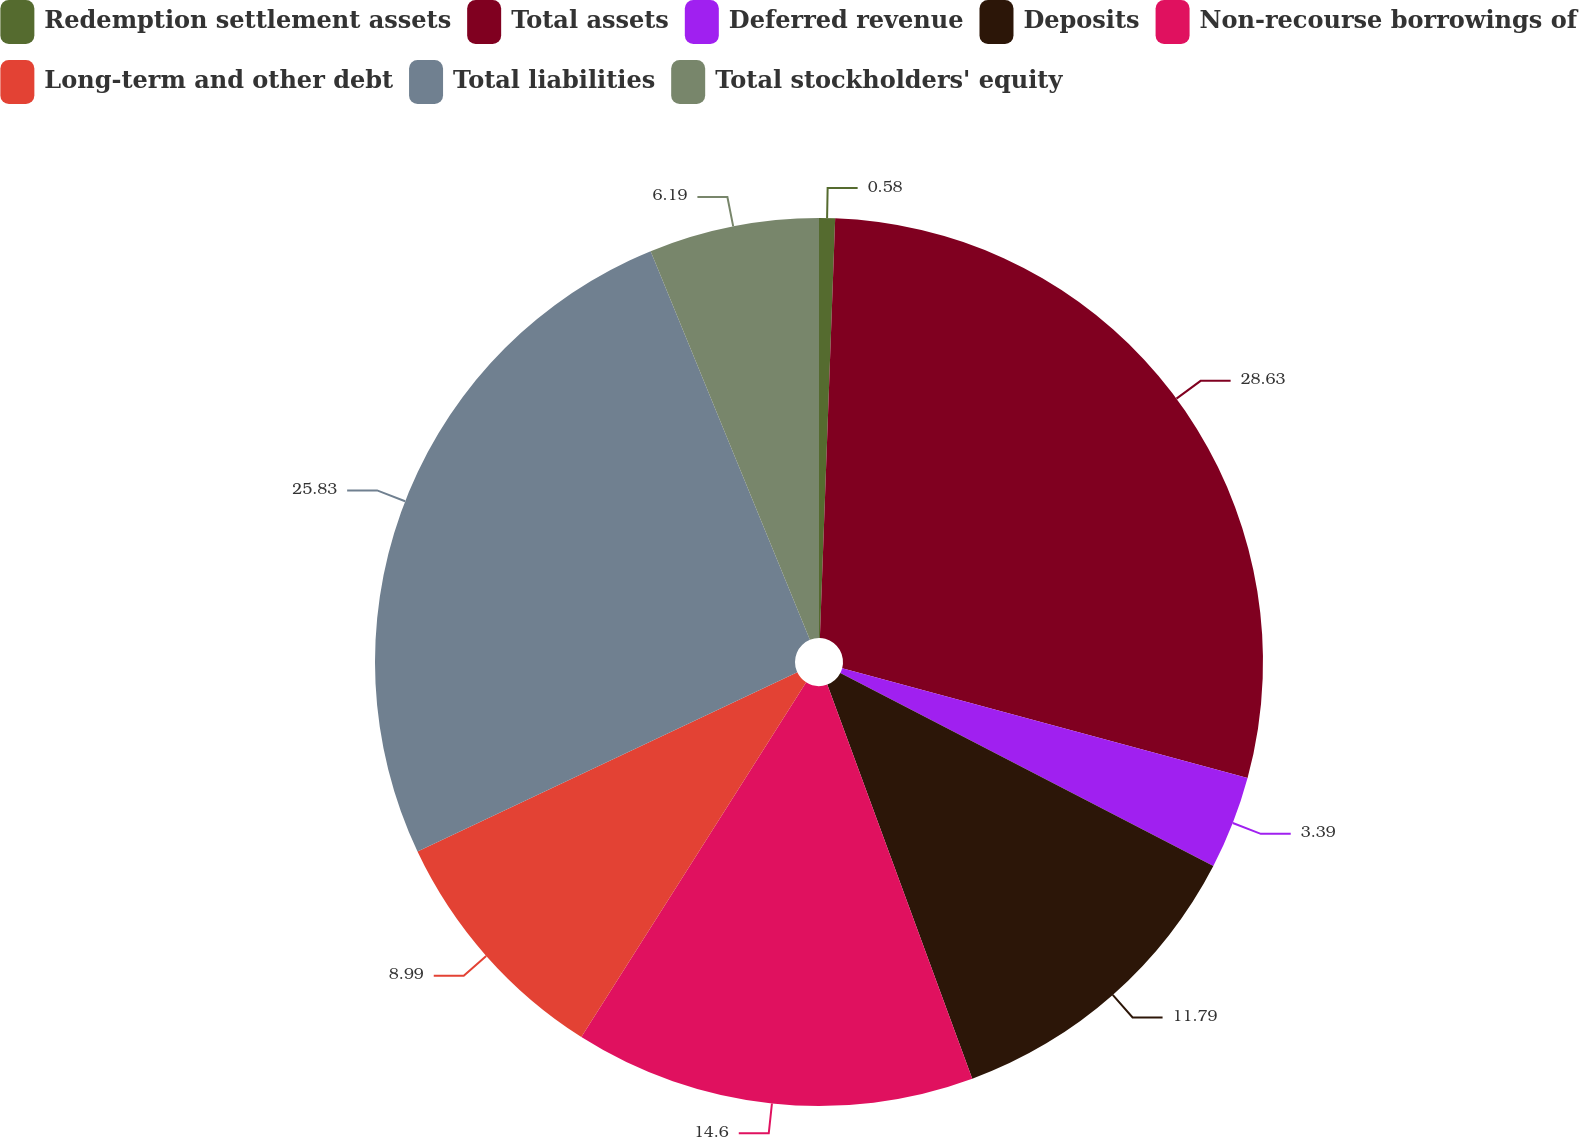Convert chart to OTSL. <chart><loc_0><loc_0><loc_500><loc_500><pie_chart><fcel>Redemption settlement assets<fcel>Total assets<fcel>Deferred revenue<fcel>Deposits<fcel>Non-recourse borrowings of<fcel>Long-term and other debt<fcel>Total liabilities<fcel>Total stockholders' equity<nl><fcel>0.58%<fcel>28.63%<fcel>3.39%<fcel>11.79%<fcel>14.6%<fcel>8.99%<fcel>25.83%<fcel>6.19%<nl></chart> 